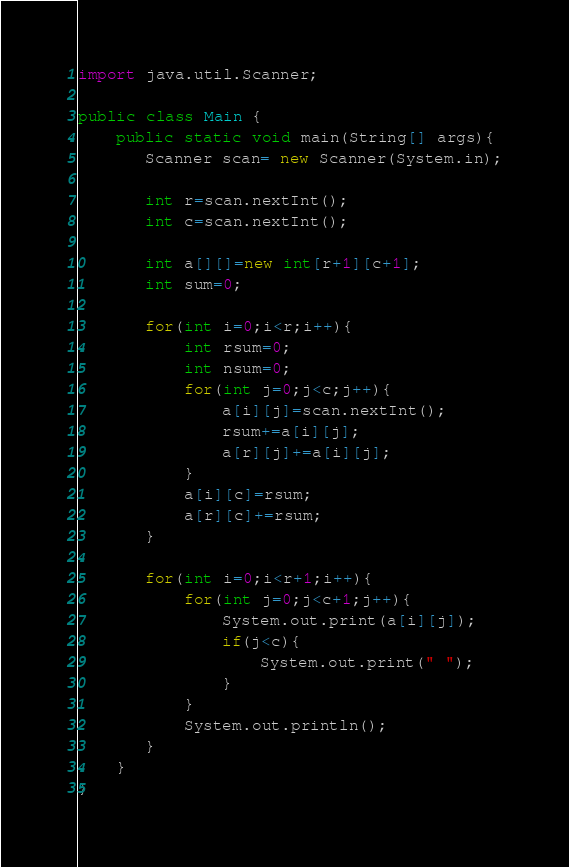<code> <loc_0><loc_0><loc_500><loc_500><_Java_>import java.util.Scanner;

public class Main {
    public static void main(String[] args){
       Scanner scan= new Scanner(System.in);

       int r=scan.nextInt();
       int c=scan.nextInt();

       int a[][]=new int[r+1][c+1];
       int sum=0;

       for(int i=0;i<r;i++){
           int rsum=0;
           int nsum=0;
           for(int j=0;j<c;j++){
               a[i][j]=scan.nextInt();
               rsum+=a[i][j];
               a[r][j]+=a[i][j];
           }
           a[i][c]=rsum;
           a[r][c]+=rsum;
       }

       for(int i=0;i<r+1;i++){
           for(int j=0;j<c+1;j++){
               System.out.print(a[i][j]);
               if(j<c){
                   System.out.print(" ");
               }
           }
           System.out.println();
       }
    }
}

</code> 